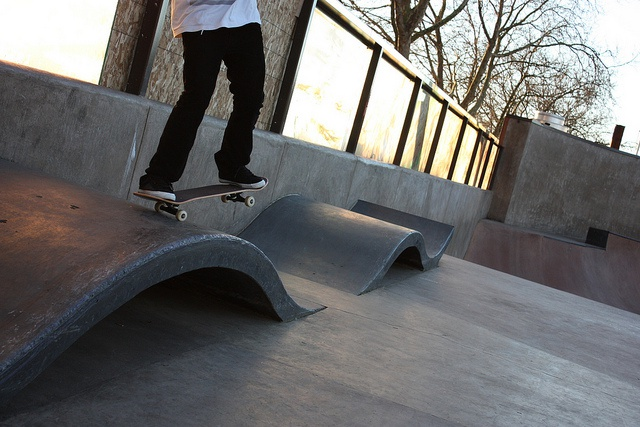Describe the objects in this image and their specific colors. I can see people in white, black, gray, and darkgray tones and skateboard in white, black, gray, and darkgray tones in this image. 